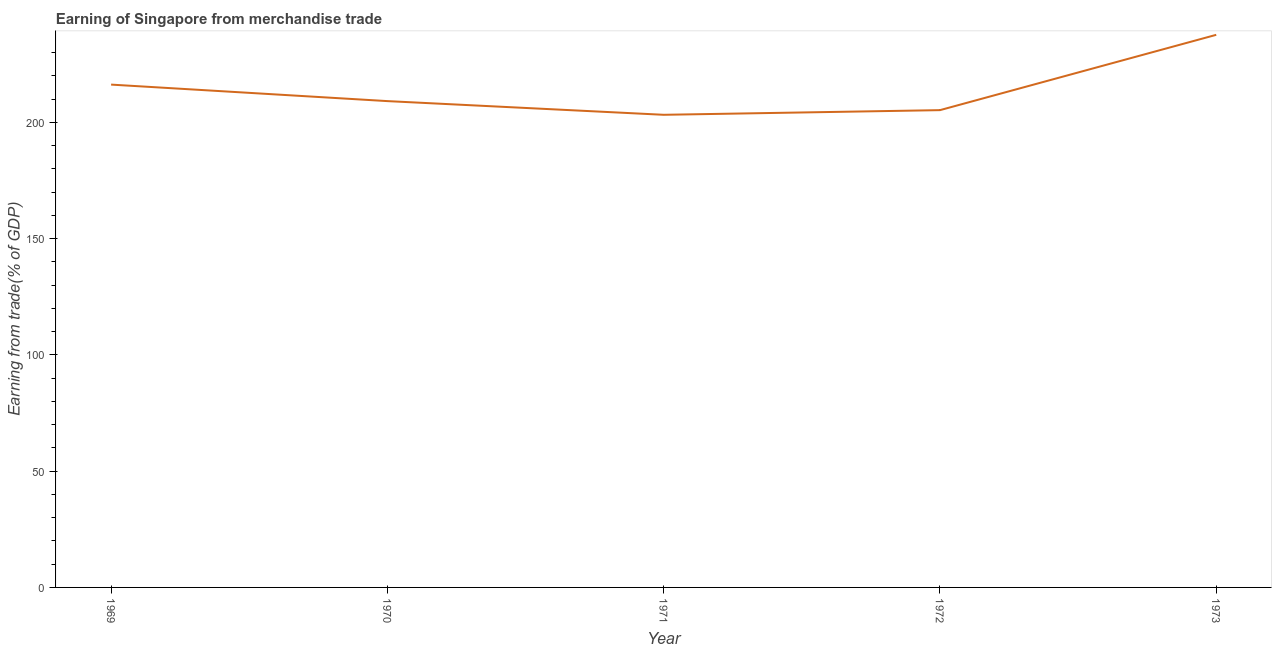What is the earning from merchandise trade in 1972?
Your response must be concise. 205.29. Across all years, what is the maximum earning from merchandise trade?
Make the answer very short. 237.69. Across all years, what is the minimum earning from merchandise trade?
Give a very brief answer. 203.29. What is the sum of the earning from merchandise trade?
Keep it short and to the point. 1071.72. What is the difference between the earning from merchandise trade in 1972 and 1973?
Make the answer very short. -32.39. What is the average earning from merchandise trade per year?
Your answer should be very brief. 214.34. What is the median earning from merchandise trade?
Keep it short and to the point. 209.17. What is the ratio of the earning from merchandise trade in 1971 to that in 1973?
Provide a succinct answer. 0.86. Is the difference between the earning from merchandise trade in 1970 and 1972 greater than the difference between any two years?
Provide a short and direct response. No. What is the difference between the highest and the second highest earning from merchandise trade?
Make the answer very short. 21.41. Is the sum of the earning from merchandise trade in 1971 and 1972 greater than the maximum earning from merchandise trade across all years?
Provide a short and direct response. Yes. What is the difference between the highest and the lowest earning from merchandise trade?
Offer a terse response. 34.4. In how many years, is the earning from merchandise trade greater than the average earning from merchandise trade taken over all years?
Provide a succinct answer. 2. Does the graph contain grids?
Provide a short and direct response. No. What is the title of the graph?
Your answer should be compact. Earning of Singapore from merchandise trade. What is the label or title of the X-axis?
Your answer should be very brief. Year. What is the label or title of the Y-axis?
Provide a short and direct response. Earning from trade(% of GDP). What is the Earning from trade(% of GDP) of 1969?
Give a very brief answer. 216.28. What is the Earning from trade(% of GDP) in 1970?
Your answer should be compact. 209.17. What is the Earning from trade(% of GDP) of 1971?
Keep it short and to the point. 203.29. What is the Earning from trade(% of GDP) of 1972?
Your response must be concise. 205.29. What is the Earning from trade(% of GDP) in 1973?
Ensure brevity in your answer.  237.69. What is the difference between the Earning from trade(% of GDP) in 1969 and 1970?
Ensure brevity in your answer.  7.1. What is the difference between the Earning from trade(% of GDP) in 1969 and 1971?
Provide a short and direct response. 12.99. What is the difference between the Earning from trade(% of GDP) in 1969 and 1972?
Provide a succinct answer. 10.98. What is the difference between the Earning from trade(% of GDP) in 1969 and 1973?
Give a very brief answer. -21.41. What is the difference between the Earning from trade(% of GDP) in 1970 and 1971?
Ensure brevity in your answer.  5.89. What is the difference between the Earning from trade(% of GDP) in 1970 and 1972?
Your answer should be compact. 3.88. What is the difference between the Earning from trade(% of GDP) in 1970 and 1973?
Ensure brevity in your answer.  -28.51. What is the difference between the Earning from trade(% of GDP) in 1971 and 1972?
Your answer should be very brief. -2. What is the difference between the Earning from trade(% of GDP) in 1971 and 1973?
Make the answer very short. -34.4. What is the difference between the Earning from trade(% of GDP) in 1972 and 1973?
Make the answer very short. -32.39. What is the ratio of the Earning from trade(% of GDP) in 1969 to that in 1970?
Make the answer very short. 1.03. What is the ratio of the Earning from trade(% of GDP) in 1969 to that in 1971?
Give a very brief answer. 1.06. What is the ratio of the Earning from trade(% of GDP) in 1969 to that in 1972?
Your response must be concise. 1.05. What is the ratio of the Earning from trade(% of GDP) in 1969 to that in 1973?
Provide a succinct answer. 0.91. What is the ratio of the Earning from trade(% of GDP) in 1970 to that in 1971?
Your response must be concise. 1.03. What is the ratio of the Earning from trade(% of GDP) in 1970 to that in 1972?
Your response must be concise. 1.02. What is the ratio of the Earning from trade(% of GDP) in 1970 to that in 1973?
Make the answer very short. 0.88. What is the ratio of the Earning from trade(% of GDP) in 1971 to that in 1972?
Your response must be concise. 0.99. What is the ratio of the Earning from trade(% of GDP) in 1971 to that in 1973?
Ensure brevity in your answer.  0.85. What is the ratio of the Earning from trade(% of GDP) in 1972 to that in 1973?
Give a very brief answer. 0.86. 